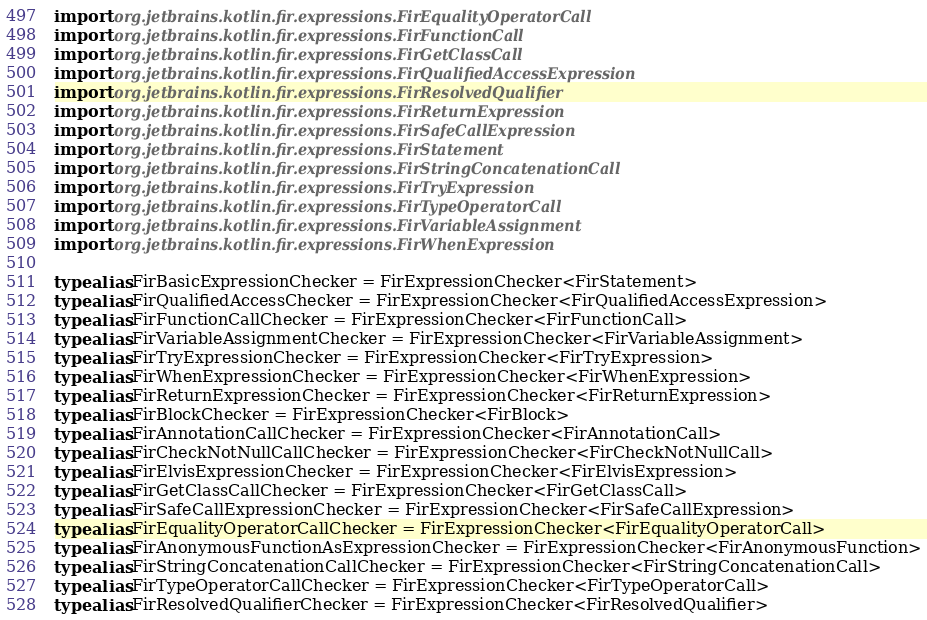Convert code to text. <code><loc_0><loc_0><loc_500><loc_500><_Kotlin_>import org.jetbrains.kotlin.fir.expressions.FirEqualityOperatorCall
import org.jetbrains.kotlin.fir.expressions.FirFunctionCall
import org.jetbrains.kotlin.fir.expressions.FirGetClassCall
import org.jetbrains.kotlin.fir.expressions.FirQualifiedAccessExpression
import org.jetbrains.kotlin.fir.expressions.FirResolvedQualifier
import org.jetbrains.kotlin.fir.expressions.FirReturnExpression
import org.jetbrains.kotlin.fir.expressions.FirSafeCallExpression
import org.jetbrains.kotlin.fir.expressions.FirStatement
import org.jetbrains.kotlin.fir.expressions.FirStringConcatenationCall
import org.jetbrains.kotlin.fir.expressions.FirTryExpression
import org.jetbrains.kotlin.fir.expressions.FirTypeOperatorCall
import org.jetbrains.kotlin.fir.expressions.FirVariableAssignment
import org.jetbrains.kotlin.fir.expressions.FirWhenExpression

typealias FirBasicExpressionChecker = FirExpressionChecker<FirStatement>
typealias FirQualifiedAccessChecker = FirExpressionChecker<FirQualifiedAccessExpression>
typealias FirFunctionCallChecker = FirExpressionChecker<FirFunctionCall>
typealias FirVariableAssignmentChecker = FirExpressionChecker<FirVariableAssignment>
typealias FirTryExpressionChecker = FirExpressionChecker<FirTryExpression>
typealias FirWhenExpressionChecker = FirExpressionChecker<FirWhenExpression>
typealias FirReturnExpressionChecker = FirExpressionChecker<FirReturnExpression>
typealias FirBlockChecker = FirExpressionChecker<FirBlock>
typealias FirAnnotationCallChecker = FirExpressionChecker<FirAnnotationCall>
typealias FirCheckNotNullCallChecker = FirExpressionChecker<FirCheckNotNullCall>
typealias FirElvisExpressionChecker = FirExpressionChecker<FirElvisExpression>
typealias FirGetClassCallChecker = FirExpressionChecker<FirGetClassCall>
typealias FirSafeCallExpressionChecker = FirExpressionChecker<FirSafeCallExpression>
typealias FirEqualityOperatorCallChecker = FirExpressionChecker<FirEqualityOperatorCall>
typealias FirAnonymousFunctionAsExpressionChecker = FirExpressionChecker<FirAnonymousFunction>
typealias FirStringConcatenationCallChecker = FirExpressionChecker<FirStringConcatenationCall>
typealias FirTypeOperatorCallChecker = FirExpressionChecker<FirTypeOperatorCall>
typealias FirResolvedQualifierChecker = FirExpressionChecker<FirResolvedQualifier>
</code> 